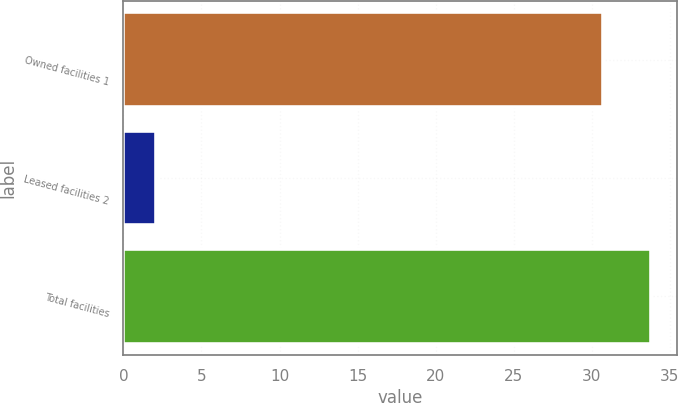Convert chart. <chart><loc_0><loc_0><loc_500><loc_500><bar_chart><fcel>Owned facilities 1<fcel>Leased facilities 2<fcel>Total facilities<nl><fcel>30.7<fcel>2.1<fcel>33.77<nl></chart> 